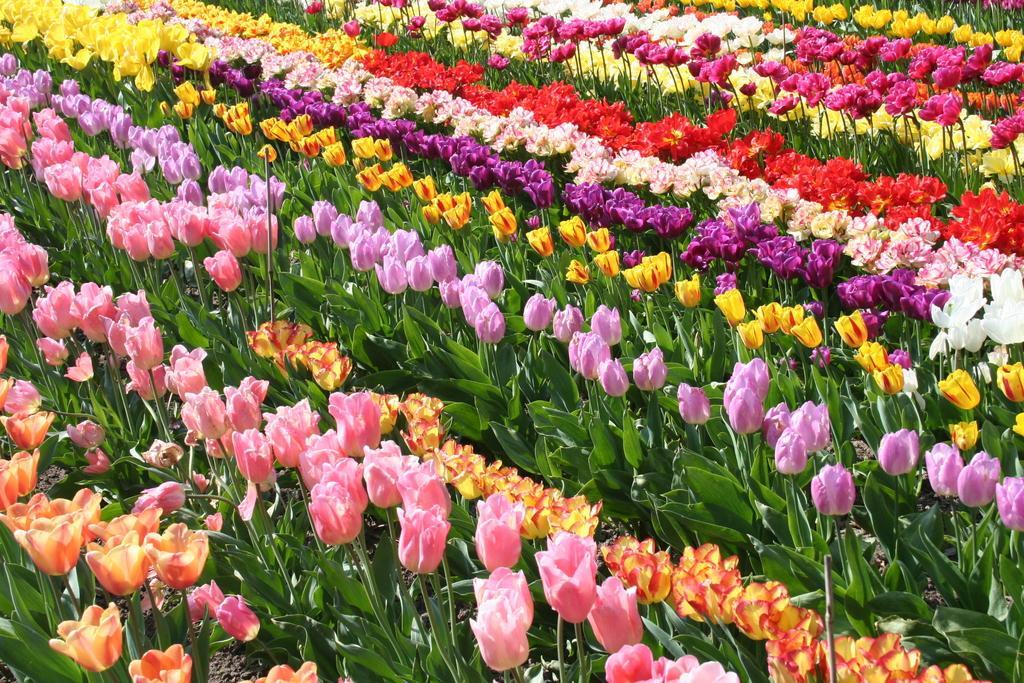Describe this image in one or two sentences. In this image, I can see the plants with colorful flowers and there are wooden sticks. 